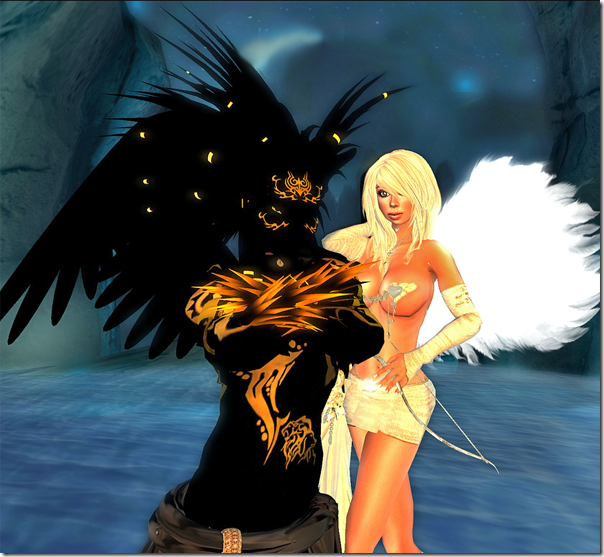What role might these characters play within their respective narrative universe considering their powerful and distinct appearances? Given their striking appearances, the characters likely hold significant roles within their narrative universe. The one with black and gold attire and dark, impactful wings might be a protector or a warrior figure, symbolizing strength and perhaps a hint of malevolence or mystique. Conversely, the character in white could represent a figure of guidance, healing, or purity. Their contrasting designs suggest that their roles could involve opposing viewpoints or alliances within their story, potentially as adversaries or complements to each other, driving the narrative with their contrasting values and powers. 